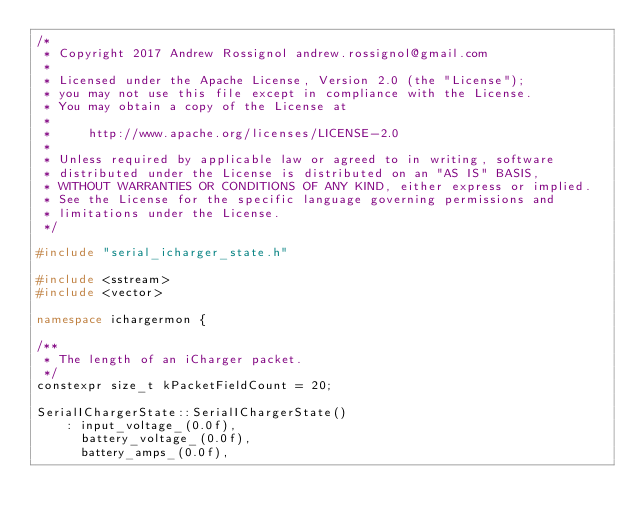Convert code to text. <code><loc_0><loc_0><loc_500><loc_500><_C++_>/*
 * Copyright 2017 Andrew Rossignol andrew.rossignol@gmail.com
 * 
 * Licensed under the Apache License, Version 2.0 (the "License");
 * you may not use this file except in compliance with the License.
 * You may obtain a copy of the License at
 * 
 *     http://www.apache.org/licenses/LICENSE-2.0
 * 
 * Unless required by applicable law or agreed to in writing, software
 * distributed under the License is distributed on an "AS IS" BASIS,
 * WITHOUT WARRANTIES OR CONDITIONS OF ANY KIND, either express or implied.
 * See the License for the specific language governing permissions and
 * limitations under the License.
 */

#include "serial_icharger_state.h"

#include <sstream>
#include <vector>

namespace ichargermon {

/**
 * The length of an iCharger packet.
 */
constexpr size_t kPacketFieldCount = 20;

SerialIChargerState::SerialIChargerState()
    : input_voltage_(0.0f),
      battery_voltage_(0.0f),
      battery_amps_(0.0f),</code> 